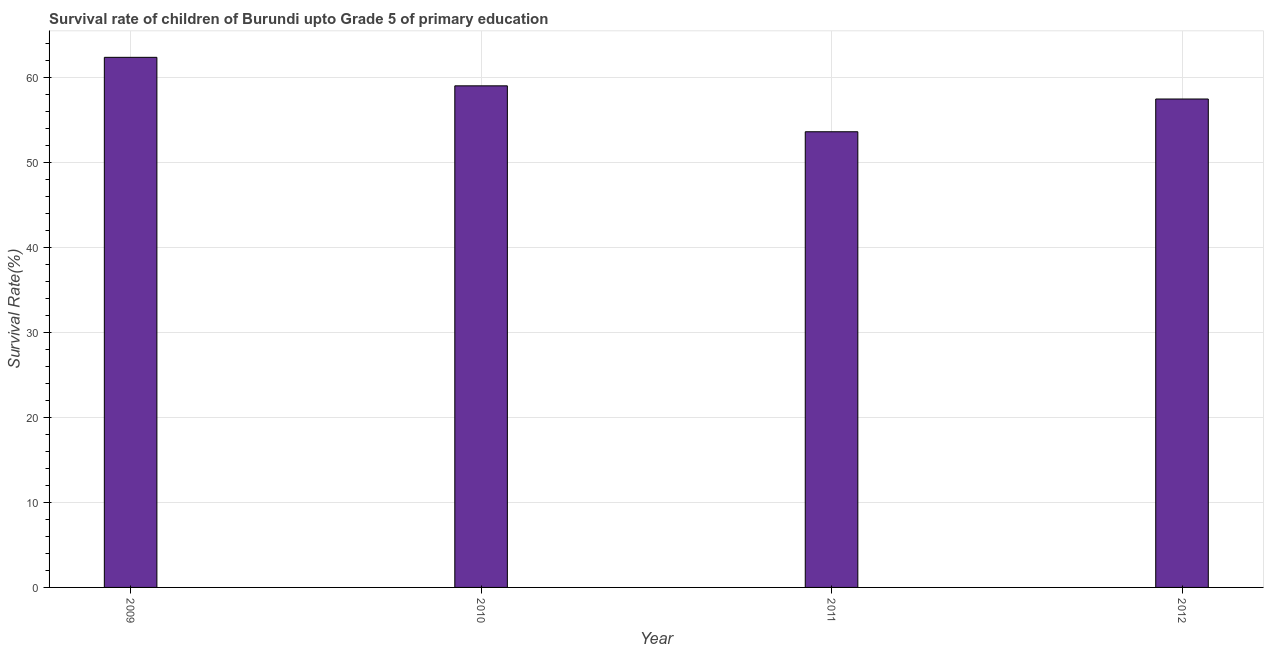What is the title of the graph?
Offer a very short reply. Survival rate of children of Burundi upto Grade 5 of primary education. What is the label or title of the X-axis?
Ensure brevity in your answer.  Year. What is the label or title of the Y-axis?
Offer a very short reply. Survival Rate(%). What is the survival rate in 2010?
Give a very brief answer. 58.99. Across all years, what is the maximum survival rate?
Make the answer very short. 62.35. Across all years, what is the minimum survival rate?
Provide a short and direct response. 53.59. What is the sum of the survival rate?
Your answer should be compact. 232.38. What is the average survival rate per year?
Ensure brevity in your answer.  58.09. What is the median survival rate?
Your answer should be compact. 58.22. Do a majority of the years between 2010 and 2012 (inclusive) have survival rate greater than 36 %?
Your answer should be compact. Yes. What is the ratio of the survival rate in 2009 to that in 2010?
Ensure brevity in your answer.  1.06. Is the difference between the survival rate in 2009 and 2011 greater than the difference between any two years?
Keep it short and to the point. Yes. What is the difference between the highest and the second highest survival rate?
Keep it short and to the point. 3.35. What is the difference between the highest and the lowest survival rate?
Make the answer very short. 8.75. In how many years, is the survival rate greater than the average survival rate taken over all years?
Make the answer very short. 2. What is the difference between two consecutive major ticks on the Y-axis?
Provide a short and direct response. 10. Are the values on the major ticks of Y-axis written in scientific E-notation?
Ensure brevity in your answer.  No. What is the Survival Rate(%) in 2009?
Your answer should be very brief. 62.35. What is the Survival Rate(%) in 2010?
Provide a short and direct response. 58.99. What is the Survival Rate(%) in 2011?
Give a very brief answer. 53.59. What is the Survival Rate(%) in 2012?
Offer a very short reply. 57.44. What is the difference between the Survival Rate(%) in 2009 and 2010?
Give a very brief answer. 3.35. What is the difference between the Survival Rate(%) in 2009 and 2011?
Provide a succinct answer. 8.75. What is the difference between the Survival Rate(%) in 2009 and 2012?
Your response must be concise. 4.9. What is the difference between the Survival Rate(%) in 2010 and 2011?
Your answer should be compact. 5.4. What is the difference between the Survival Rate(%) in 2010 and 2012?
Offer a very short reply. 1.55. What is the difference between the Survival Rate(%) in 2011 and 2012?
Provide a succinct answer. -3.85. What is the ratio of the Survival Rate(%) in 2009 to that in 2010?
Offer a terse response. 1.06. What is the ratio of the Survival Rate(%) in 2009 to that in 2011?
Provide a short and direct response. 1.16. What is the ratio of the Survival Rate(%) in 2009 to that in 2012?
Your answer should be very brief. 1.08. What is the ratio of the Survival Rate(%) in 2010 to that in 2011?
Provide a succinct answer. 1.1. What is the ratio of the Survival Rate(%) in 2010 to that in 2012?
Offer a terse response. 1.03. What is the ratio of the Survival Rate(%) in 2011 to that in 2012?
Keep it short and to the point. 0.93. 